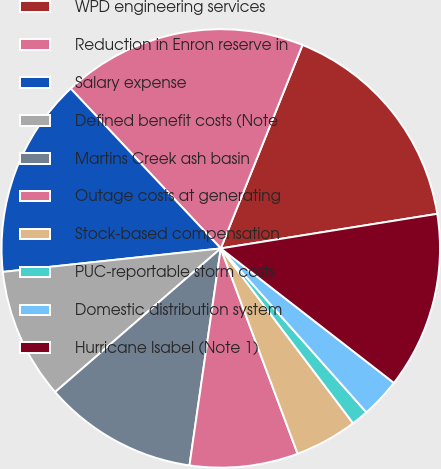<chart> <loc_0><loc_0><loc_500><loc_500><pie_chart><fcel>WPD engineering services<fcel>Reduction in Enron reserve in<fcel>Salary expense<fcel>Defined benefit costs (Note<fcel>Martins Creek ash basin<fcel>Outage costs at generating<fcel>Stock-based compensation<fcel>PUC-reportable storm costs<fcel>Domestic distribution system<fcel>Hurricane Isabel (Note 1)<nl><fcel>16.4%<fcel>18.08%<fcel>14.71%<fcel>9.66%<fcel>11.35%<fcel>7.98%<fcel>4.61%<fcel>1.25%<fcel>2.93%<fcel>13.03%<nl></chart> 